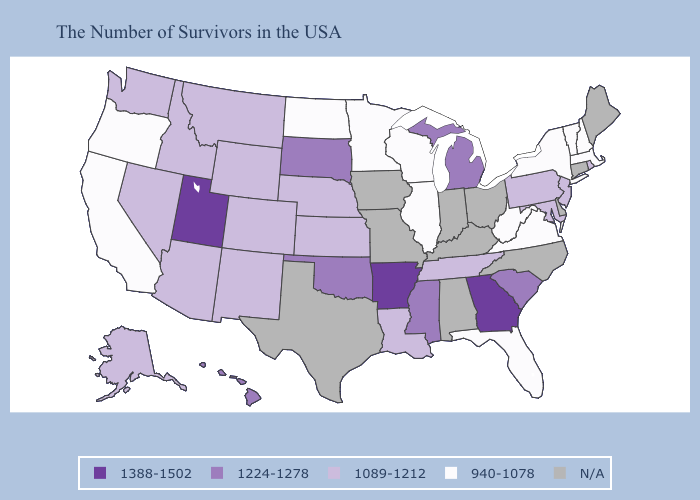What is the highest value in the USA?
Answer briefly. 1388-1502. Does Vermont have the lowest value in the Northeast?
Keep it brief. Yes. Which states have the highest value in the USA?
Concise answer only. Georgia, Arkansas, Utah. What is the highest value in the USA?
Write a very short answer. 1388-1502. Name the states that have a value in the range 1224-1278?
Concise answer only. South Carolina, Michigan, Mississippi, Oklahoma, South Dakota, Hawaii. Which states have the highest value in the USA?
Quick response, please. Georgia, Arkansas, Utah. What is the lowest value in the USA?
Be succinct. 940-1078. How many symbols are there in the legend?
Concise answer only. 5. Name the states that have a value in the range 1388-1502?
Be succinct. Georgia, Arkansas, Utah. Name the states that have a value in the range N/A?
Concise answer only. Maine, Connecticut, Delaware, North Carolina, Ohio, Kentucky, Indiana, Alabama, Missouri, Iowa, Texas. Which states have the lowest value in the USA?
Be succinct. Massachusetts, New Hampshire, Vermont, New York, Virginia, West Virginia, Florida, Wisconsin, Illinois, Minnesota, North Dakota, California, Oregon. What is the lowest value in the USA?
Write a very short answer. 940-1078. Name the states that have a value in the range N/A?
Give a very brief answer. Maine, Connecticut, Delaware, North Carolina, Ohio, Kentucky, Indiana, Alabama, Missouri, Iowa, Texas. What is the lowest value in the USA?
Keep it brief. 940-1078. Does the first symbol in the legend represent the smallest category?
Answer briefly. No. 